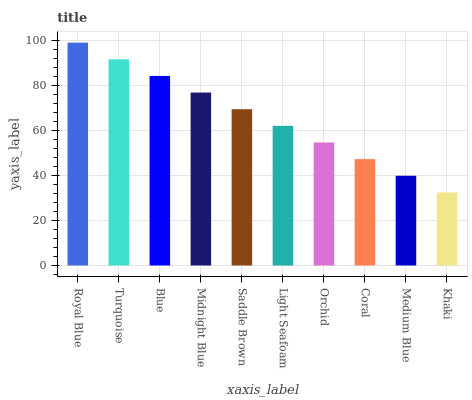Is Khaki the minimum?
Answer yes or no. Yes. Is Royal Blue the maximum?
Answer yes or no. Yes. Is Turquoise the minimum?
Answer yes or no. No. Is Turquoise the maximum?
Answer yes or no. No. Is Royal Blue greater than Turquoise?
Answer yes or no. Yes. Is Turquoise less than Royal Blue?
Answer yes or no. Yes. Is Turquoise greater than Royal Blue?
Answer yes or no. No. Is Royal Blue less than Turquoise?
Answer yes or no. No. Is Saddle Brown the high median?
Answer yes or no. Yes. Is Light Seafoam the low median?
Answer yes or no. Yes. Is Midnight Blue the high median?
Answer yes or no. No. Is Medium Blue the low median?
Answer yes or no. No. 